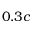Convert formula to latex. <formula><loc_0><loc_0><loc_500><loc_500>0 . 3 c</formula> 